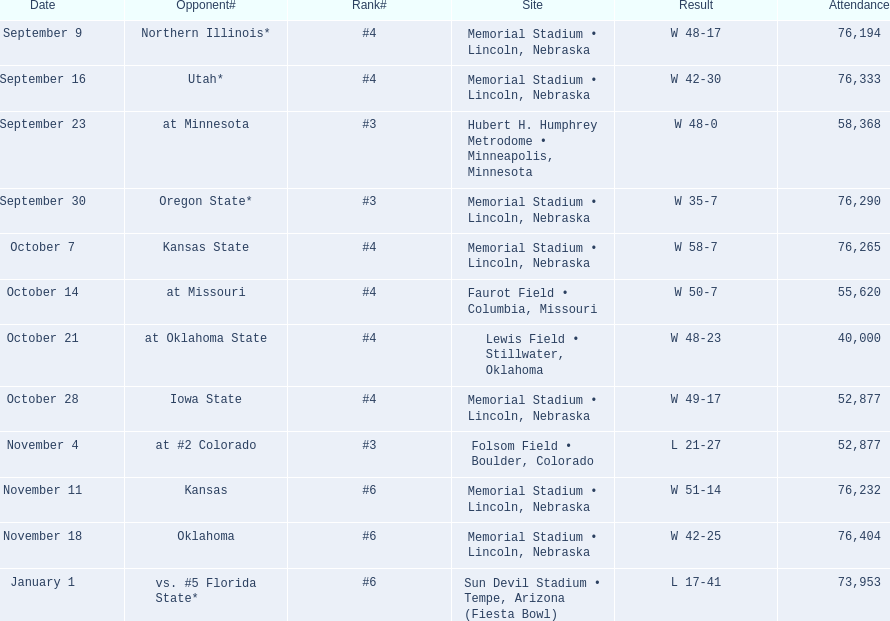Who were all their rivals? Northern Illinois*, Utah*, at Minnesota, Oregon State*, Kansas State, at Missouri, at Oklahoma State, Iowa State, at #2 Colorado, Kansas, Oklahoma, vs. #5 Florida State*. And what was the turnout at these events? 76,194, 76,333, 58,368, 76,290, 76,265, 55,620, 40,000, 52,877, 52,877, 76,232, 76,404, 73,953. Of those statistics, which is connected to the oregon state game? 76,290. 